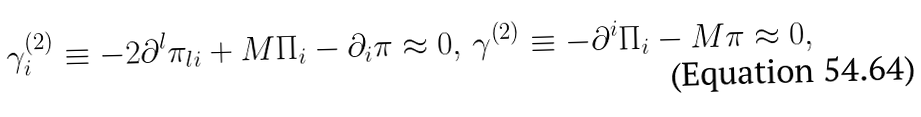Convert formula to latex. <formula><loc_0><loc_0><loc_500><loc_500>\gamma _ { i } ^ { \left ( 2 \right ) } \equiv - 2 \partial ^ { l } \pi _ { l i } + M \Pi _ { i } - \partial _ { i } \pi \approx 0 , \, \gamma ^ { \left ( 2 \right ) } \equiv - \partial ^ { i } \Pi _ { i } - M \pi \approx 0 ,</formula> 